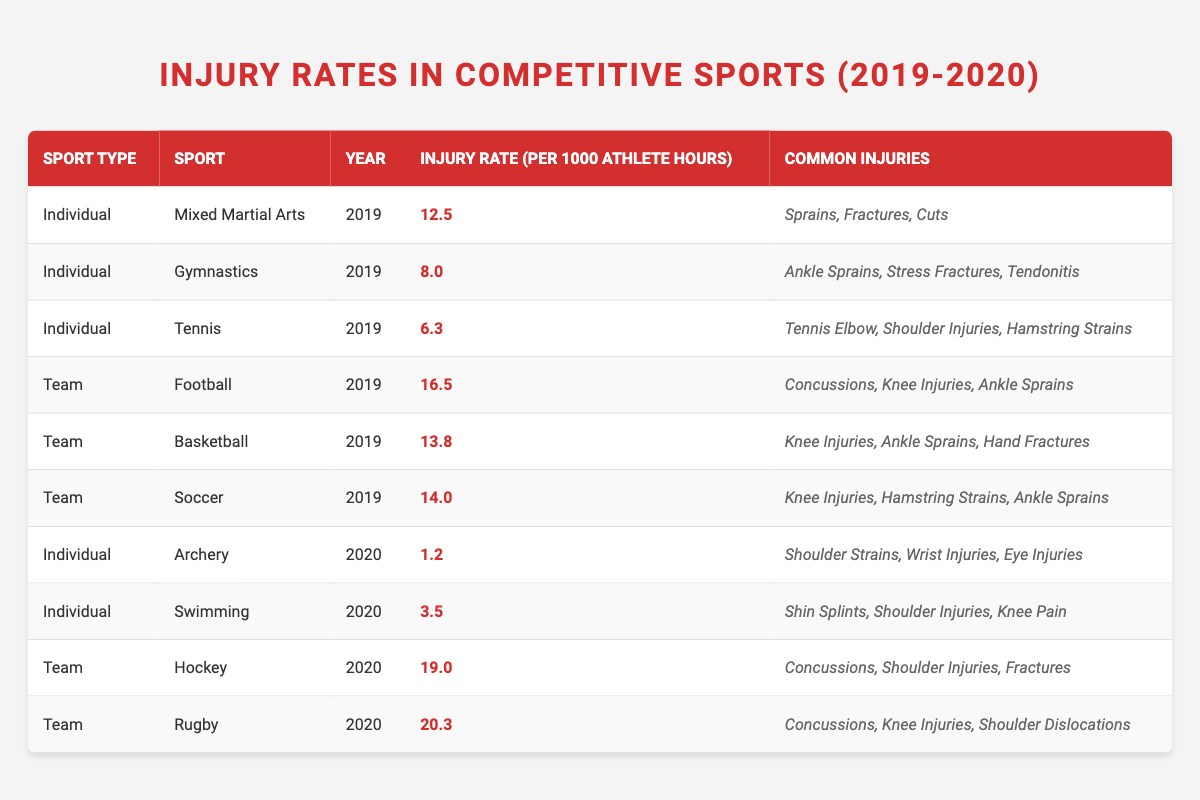What was the injury rate for Mixed Martial Arts in 2019? The table shows that the injury rate for Mixed Martial Arts in 2019 is listed as 12.5 per 1000 athlete hours.
Answer: 12.5 What are the common injuries associated with swimming in 2020? From the table, the common injuries for swimming in 2020 are listed as shin splints, shoulder injuries, and knee pain.
Answer: Shin splints, shoulder injuries, knee pain Which sport had the highest injury rate in 2020? The highest injury rate in 2020 is seen in rugby, with an injury rate of 20.3 per 1000 athlete hours as shown in the table.
Answer: Rugby What is the difference in injury rates between football and basketball in 2019? According to the table, football had an injury rate of 16.5 and basketball had an injury rate of 13.8 in 2019. The difference is calculated as 16.5 - 13.8 = 2.7 per 1000 athlete hours.
Answer: 2.7 Is the injury rate for individual sports generally lower than that for team sports in 2019? By comparing the injury rates from the table, individual sports have injury rates of 12.5, 8.0, and 6.3, while team sports have rates of 16.5, 13.8, and 14.0. The average for individual sports is roughly 8.6, while for team sports it is approximately 14.1. Thus, it is true that individual sports generally exhibit lower injury rates.
Answer: Yes What is the average injury rate for individual sports over the years represented? The injury rates for individual sports are 12.5 (Mixed Martial Arts), 8.0 (Gymnastics), 6.3 (Tennis) in 2019 and 1.2 (Archery) and 3.5 (Swimming) in 2020. Adding these gives a total of 31.5, and dividing by 5 (the number of data points) results in an average of 6.3 per 1000 athlete hours.
Answer: 6.3 